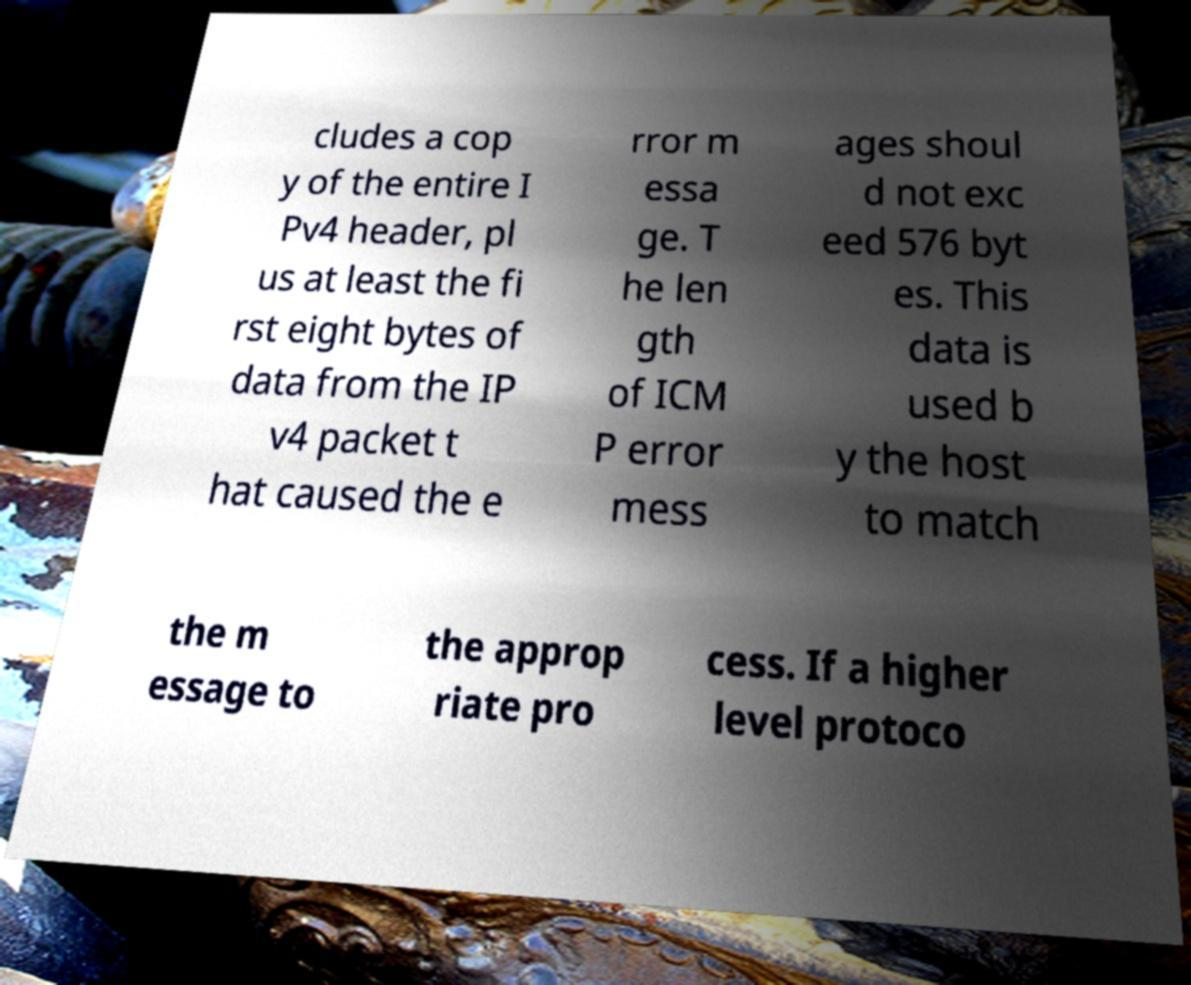There's text embedded in this image that I need extracted. Can you transcribe it verbatim? cludes a cop y of the entire I Pv4 header, pl us at least the fi rst eight bytes of data from the IP v4 packet t hat caused the e rror m essa ge. T he len gth of ICM P error mess ages shoul d not exc eed 576 byt es. This data is used b y the host to match the m essage to the approp riate pro cess. If a higher level protoco 